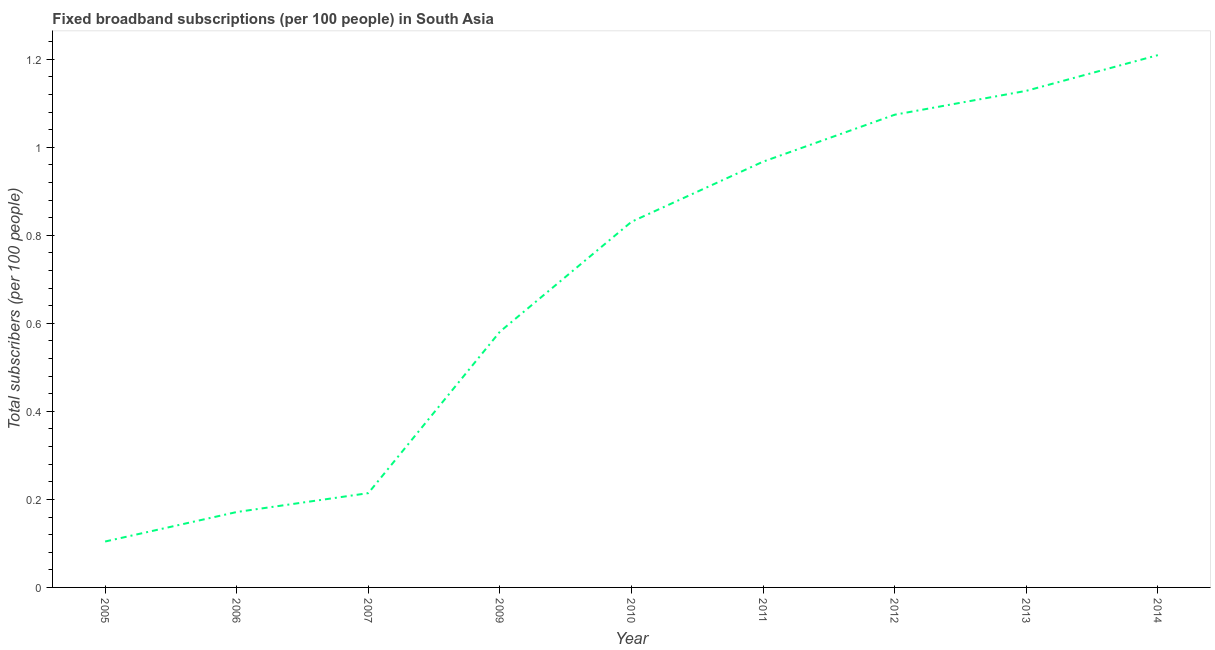What is the total number of fixed broadband subscriptions in 2012?
Provide a short and direct response. 1.07. Across all years, what is the maximum total number of fixed broadband subscriptions?
Offer a terse response. 1.21. Across all years, what is the minimum total number of fixed broadband subscriptions?
Provide a succinct answer. 0.1. In which year was the total number of fixed broadband subscriptions minimum?
Offer a very short reply. 2005. What is the sum of the total number of fixed broadband subscriptions?
Keep it short and to the point. 6.28. What is the difference between the total number of fixed broadband subscriptions in 2011 and 2013?
Ensure brevity in your answer.  -0.16. What is the average total number of fixed broadband subscriptions per year?
Provide a succinct answer. 0.7. What is the median total number of fixed broadband subscriptions?
Your response must be concise. 0.83. In how many years, is the total number of fixed broadband subscriptions greater than 0.08 ?
Keep it short and to the point. 9. Do a majority of the years between 2011 and 2014 (inclusive) have total number of fixed broadband subscriptions greater than 0.7200000000000001 ?
Provide a succinct answer. Yes. What is the ratio of the total number of fixed broadband subscriptions in 2010 to that in 2012?
Provide a succinct answer. 0.77. Is the total number of fixed broadband subscriptions in 2007 less than that in 2013?
Make the answer very short. Yes. What is the difference between the highest and the second highest total number of fixed broadband subscriptions?
Your response must be concise. 0.08. What is the difference between the highest and the lowest total number of fixed broadband subscriptions?
Provide a short and direct response. 1.11. Does the total number of fixed broadband subscriptions monotonically increase over the years?
Make the answer very short. Yes. What is the difference between two consecutive major ticks on the Y-axis?
Provide a succinct answer. 0.2. Are the values on the major ticks of Y-axis written in scientific E-notation?
Keep it short and to the point. No. Does the graph contain grids?
Your answer should be very brief. No. What is the title of the graph?
Your answer should be very brief. Fixed broadband subscriptions (per 100 people) in South Asia. What is the label or title of the X-axis?
Give a very brief answer. Year. What is the label or title of the Y-axis?
Offer a terse response. Total subscribers (per 100 people). What is the Total subscribers (per 100 people) of 2005?
Your answer should be very brief. 0.1. What is the Total subscribers (per 100 people) in 2006?
Make the answer very short. 0.17. What is the Total subscribers (per 100 people) of 2007?
Give a very brief answer. 0.21. What is the Total subscribers (per 100 people) in 2009?
Your answer should be compact. 0.58. What is the Total subscribers (per 100 people) in 2010?
Give a very brief answer. 0.83. What is the Total subscribers (per 100 people) of 2011?
Give a very brief answer. 0.97. What is the Total subscribers (per 100 people) of 2012?
Offer a very short reply. 1.07. What is the Total subscribers (per 100 people) of 2013?
Provide a short and direct response. 1.13. What is the Total subscribers (per 100 people) in 2014?
Offer a terse response. 1.21. What is the difference between the Total subscribers (per 100 people) in 2005 and 2006?
Provide a short and direct response. -0.07. What is the difference between the Total subscribers (per 100 people) in 2005 and 2007?
Offer a very short reply. -0.11. What is the difference between the Total subscribers (per 100 people) in 2005 and 2009?
Ensure brevity in your answer.  -0.48. What is the difference between the Total subscribers (per 100 people) in 2005 and 2010?
Offer a terse response. -0.73. What is the difference between the Total subscribers (per 100 people) in 2005 and 2011?
Give a very brief answer. -0.86. What is the difference between the Total subscribers (per 100 people) in 2005 and 2012?
Give a very brief answer. -0.97. What is the difference between the Total subscribers (per 100 people) in 2005 and 2013?
Offer a very short reply. -1.02. What is the difference between the Total subscribers (per 100 people) in 2005 and 2014?
Ensure brevity in your answer.  -1.11. What is the difference between the Total subscribers (per 100 people) in 2006 and 2007?
Your response must be concise. -0.04. What is the difference between the Total subscribers (per 100 people) in 2006 and 2009?
Offer a terse response. -0.41. What is the difference between the Total subscribers (per 100 people) in 2006 and 2010?
Ensure brevity in your answer.  -0.66. What is the difference between the Total subscribers (per 100 people) in 2006 and 2011?
Your response must be concise. -0.8. What is the difference between the Total subscribers (per 100 people) in 2006 and 2012?
Ensure brevity in your answer.  -0.9. What is the difference between the Total subscribers (per 100 people) in 2006 and 2013?
Make the answer very short. -0.96. What is the difference between the Total subscribers (per 100 people) in 2006 and 2014?
Make the answer very short. -1.04. What is the difference between the Total subscribers (per 100 people) in 2007 and 2009?
Offer a very short reply. -0.37. What is the difference between the Total subscribers (per 100 people) in 2007 and 2010?
Make the answer very short. -0.62. What is the difference between the Total subscribers (per 100 people) in 2007 and 2011?
Offer a terse response. -0.75. What is the difference between the Total subscribers (per 100 people) in 2007 and 2012?
Your response must be concise. -0.86. What is the difference between the Total subscribers (per 100 people) in 2007 and 2013?
Your answer should be very brief. -0.91. What is the difference between the Total subscribers (per 100 people) in 2007 and 2014?
Provide a short and direct response. -1. What is the difference between the Total subscribers (per 100 people) in 2009 and 2010?
Offer a very short reply. -0.25. What is the difference between the Total subscribers (per 100 people) in 2009 and 2011?
Make the answer very short. -0.39. What is the difference between the Total subscribers (per 100 people) in 2009 and 2012?
Ensure brevity in your answer.  -0.49. What is the difference between the Total subscribers (per 100 people) in 2009 and 2013?
Your answer should be compact. -0.55. What is the difference between the Total subscribers (per 100 people) in 2009 and 2014?
Provide a succinct answer. -0.63. What is the difference between the Total subscribers (per 100 people) in 2010 and 2011?
Your answer should be very brief. -0.14. What is the difference between the Total subscribers (per 100 people) in 2010 and 2012?
Your answer should be compact. -0.24. What is the difference between the Total subscribers (per 100 people) in 2010 and 2013?
Your answer should be compact. -0.3. What is the difference between the Total subscribers (per 100 people) in 2010 and 2014?
Offer a terse response. -0.38. What is the difference between the Total subscribers (per 100 people) in 2011 and 2012?
Give a very brief answer. -0.11. What is the difference between the Total subscribers (per 100 people) in 2011 and 2013?
Offer a terse response. -0.16. What is the difference between the Total subscribers (per 100 people) in 2011 and 2014?
Ensure brevity in your answer.  -0.24. What is the difference between the Total subscribers (per 100 people) in 2012 and 2013?
Ensure brevity in your answer.  -0.05. What is the difference between the Total subscribers (per 100 people) in 2012 and 2014?
Offer a terse response. -0.14. What is the difference between the Total subscribers (per 100 people) in 2013 and 2014?
Provide a succinct answer. -0.08. What is the ratio of the Total subscribers (per 100 people) in 2005 to that in 2006?
Offer a very short reply. 0.61. What is the ratio of the Total subscribers (per 100 people) in 2005 to that in 2007?
Provide a succinct answer. 0.49. What is the ratio of the Total subscribers (per 100 people) in 2005 to that in 2009?
Your response must be concise. 0.18. What is the ratio of the Total subscribers (per 100 people) in 2005 to that in 2010?
Offer a terse response. 0.13. What is the ratio of the Total subscribers (per 100 people) in 2005 to that in 2011?
Give a very brief answer. 0.11. What is the ratio of the Total subscribers (per 100 people) in 2005 to that in 2012?
Make the answer very short. 0.1. What is the ratio of the Total subscribers (per 100 people) in 2005 to that in 2013?
Your response must be concise. 0.09. What is the ratio of the Total subscribers (per 100 people) in 2005 to that in 2014?
Offer a very short reply. 0.09. What is the ratio of the Total subscribers (per 100 people) in 2006 to that in 2007?
Your answer should be compact. 0.8. What is the ratio of the Total subscribers (per 100 people) in 2006 to that in 2009?
Your answer should be compact. 0.29. What is the ratio of the Total subscribers (per 100 people) in 2006 to that in 2010?
Provide a short and direct response. 0.21. What is the ratio of the Total subscribers (per 100 people) in 2006 to that in 2011?
Make the answer very short. 0.18. What is the ratio of the Total subscribers (per 100 people) in 2006 to that in 2012?
Your response must be concise. 0.16. What is the ratio of the Total subscribers (per 100 people) in 2006 to that in 2013?
Ensure brevity in your answer.  0.15. What is the ratio of the Total subscribers (per 100 people) in 2006 to that in 2014?
Ensure brevity in your answer.  0.14. What is the ratio of the Total subscribers (per 100 people) in 2007 to that in 2009?
Give a very brief answer. 0.37. What is the ratio of the Total subscribers (per 100 people) in 2007 to that in 2010?
Provide a short and direct response. 0.26. What is the ratio of the Total subscribers (per 100 people) in 2007 to that in 2011?
Your answer should be very brief. 0.22. What is the ratio of the Total subscribers (per 100 people) in 2007 to that in 2012?
Provide a short and direct response. 0.2. What is the ratio of the Total subscribers (per 100 people) in 2007 to that in 2013?
Make the answer very short. 0.19. What is the ratio of the Total subscribers (per 100 people) in 2007 to that in 2014?
Ensure brevity in your answer.  0.18. What is the ratio of the Total subscribers (per 100 people) in 2009 to that in 2010?
Your answer should be compact. 0.7. What is the ratio of the Total subscribers (per 100 people) in 2009 to that in 2011?
Offer a terse response. 0.6. What is the ratio of the Total subscribers (per 100 people) in 2009 to that in 2012?
Ensure brevity in your answer.  0.54. What is the ratio of the Total subscribers (per 100 people) in 2009 to that in 2013?
Give a very brief answer. 0.52. What is the ratio of the Total subscribers (per 100 people) in 2009 to that in 2014?
Your response must be concise. 0.48. What is the ratio of the Total subscribers (per 100 people) in 2010 to that in 2011?
Make the answer very short. 0.86. What is the ratio of the Total subscribers (per 100 people) in 2010 to that in 2012?
Provide a succinct answer. 0.77. What is the ratio of the Total subscribers (per 100 people) in 2010 to that in 2013?
Your answer should be very brief. 0.74. What is the ratio of the Total subscribers (per 100 people) in 2010 to that in 2014?
Ensure brevity in your answer.  0.69. What is the ratio of the Total subscribers (per 100 people) in 2011 to that in 2012?
Ensure brevity in your answer.  0.9. What is the ratio of the Total subscribers (per 100 people) in 2011 to that in 2013?
Your answer should be compact. 0.86. What is the ratio of the Total subscribers (per 100 people) in 2011 to that in 2014?
Your response must be concise. 0.8. What is the ratio of the Total subscribers (per 100 people) in 2012 to that in 2014?
Keep it short and to the point. 0.89. What is the ratio of the Total subscribers (per 100 people) in 2013 to that in 2014?
Your answer should be compact. 0.93. 